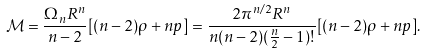Convert formula to latex. <formula><loc_0><loc_0><loc_500><loc_500>\mathcal { M } = \frac { \Omega _ { n } R ^ { n } } { n - 2 } [ ( n - 2 ) \rho + n p ] = \frac { 2 \pi ^ { n / 2 } R ^ { n } } { n ( n - 2 ) ( \frac { n } { 2 } - 1 ) ! } [ ( n - 2 ) \rho + n p ] .</formula> 